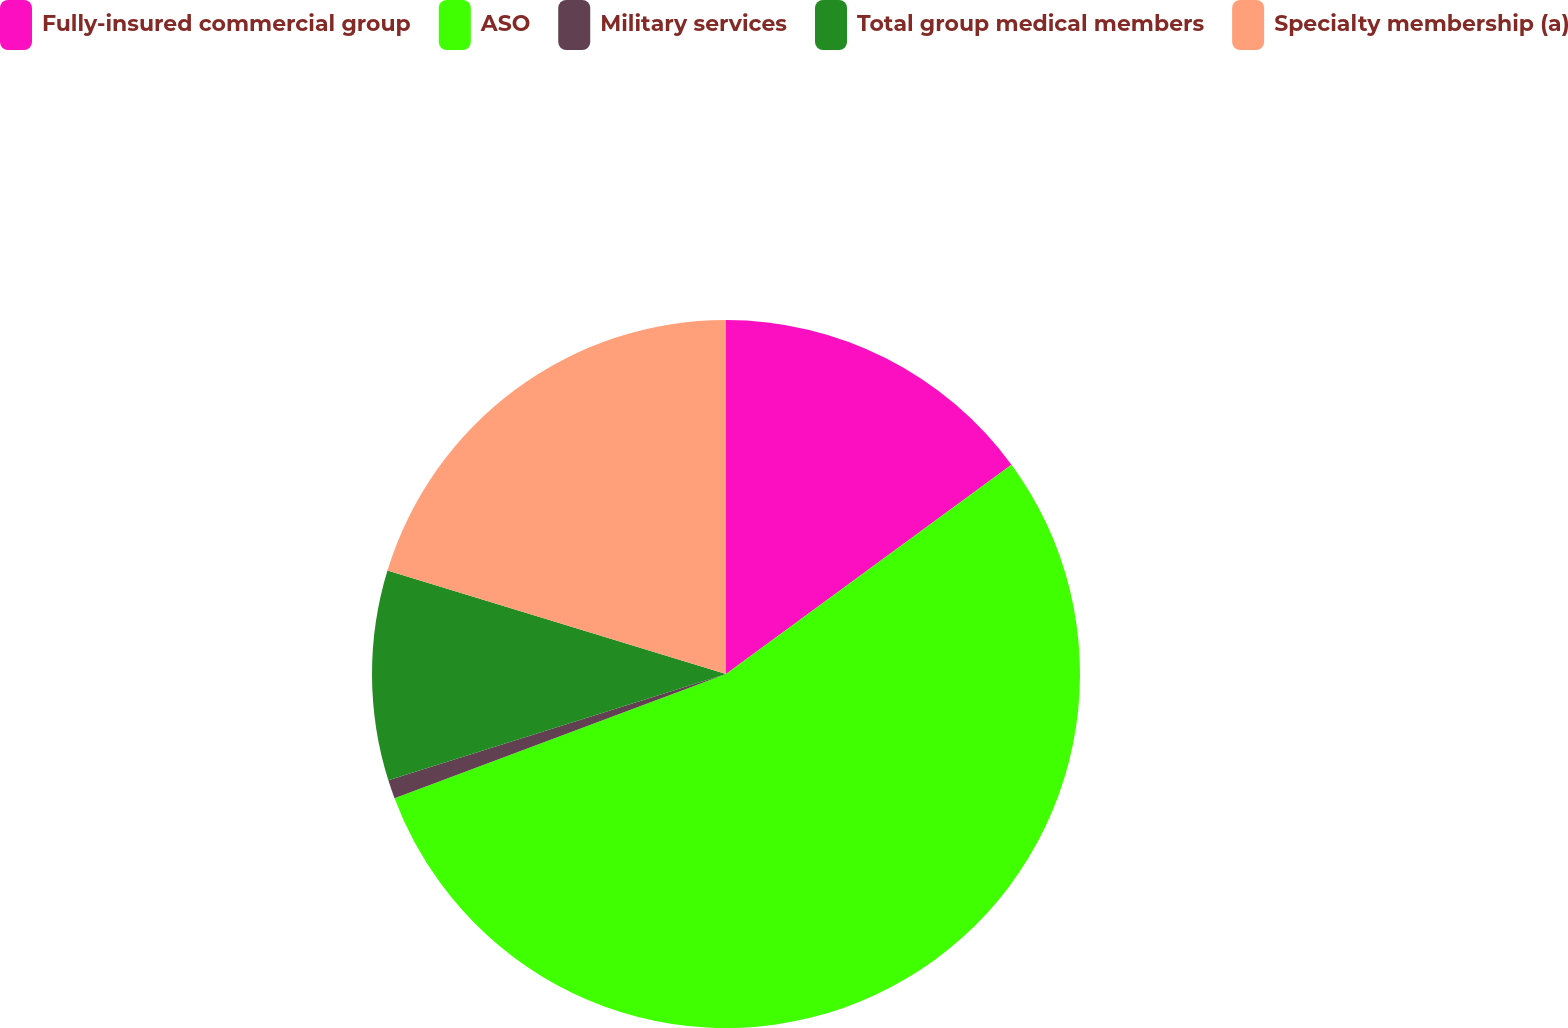Convert chart. <chart><loc_0><loc_0><loc_500><loc_500><pie_chart><fcel>Fully-insured commercial group<fcel>ASO<fcel>Military services<fcel>Total group medical members<fcel>Specialty membership (a)<nl><fcel>14.93%<fcel>54.37%<fcel>0.85%<fcel>9.58%<fcel>20.28%<nl></chart> 